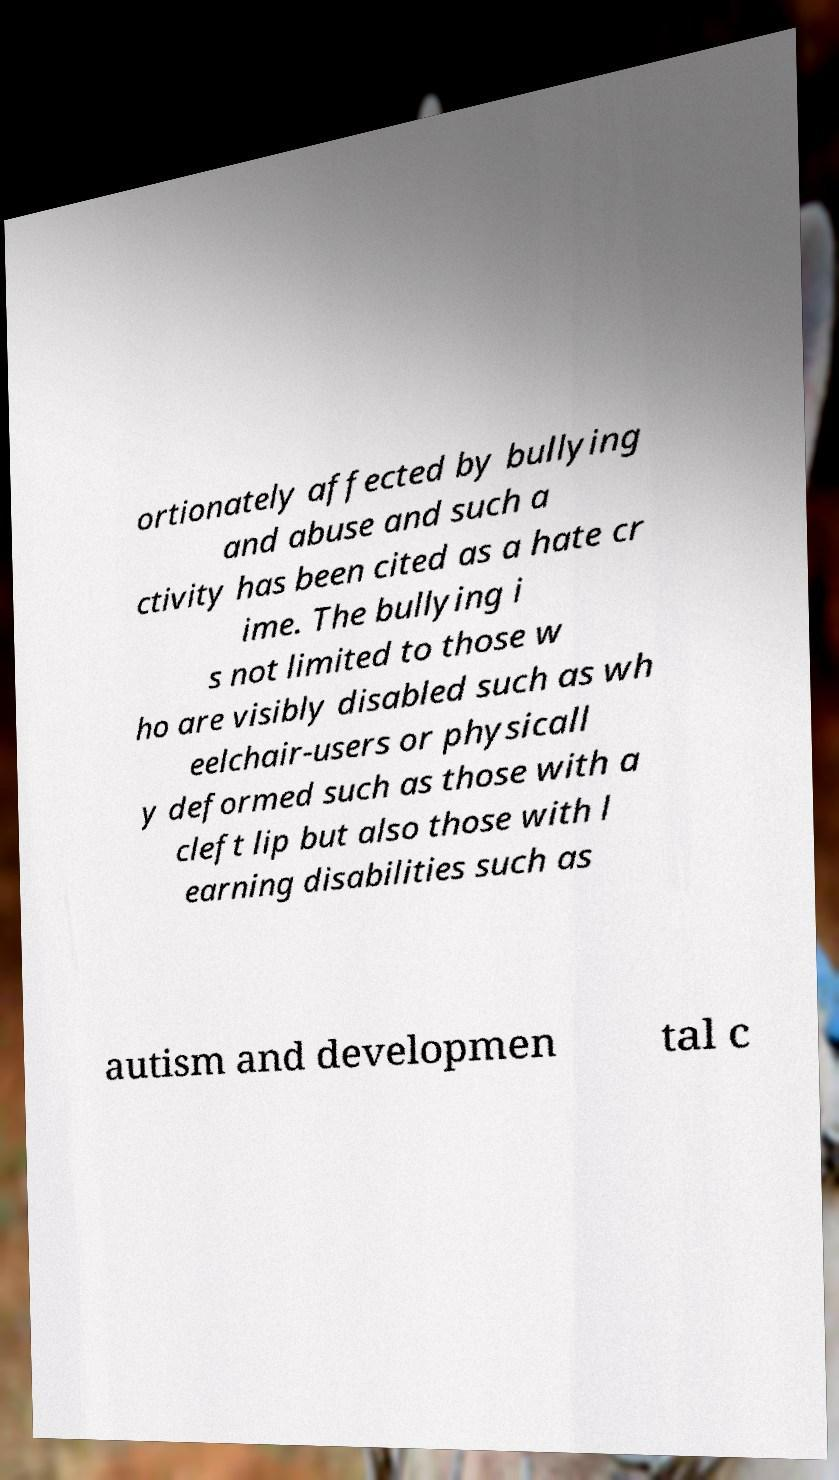Please read and relay the text visible in this image. What does it say? ortionately affected by bullying and abuse and such a ctivity has been cited as a hate cr ime. The bullying i s not limited to those w ho are visibly disabled such as wh eelchair-users or physicall y deformed such as those with a cleft lip but also those with l earning disabilities such as autism and developmen tal c 